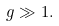<formula> <loc_0><loc_0><loc_500><loc_500>g \gg 1 .</formula> 